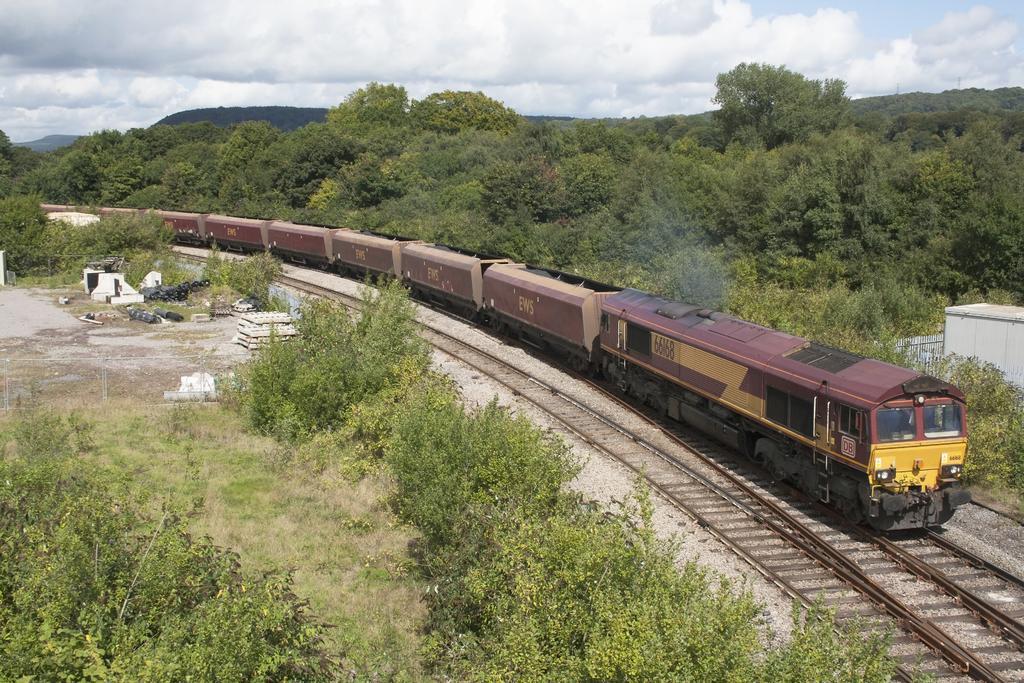Can you describe this image briefly? In the picture we can see a railway track on it, we can see a train and besides the train we can see, full of plants and trees and in the background also we can see trees and a sky with clouds. 